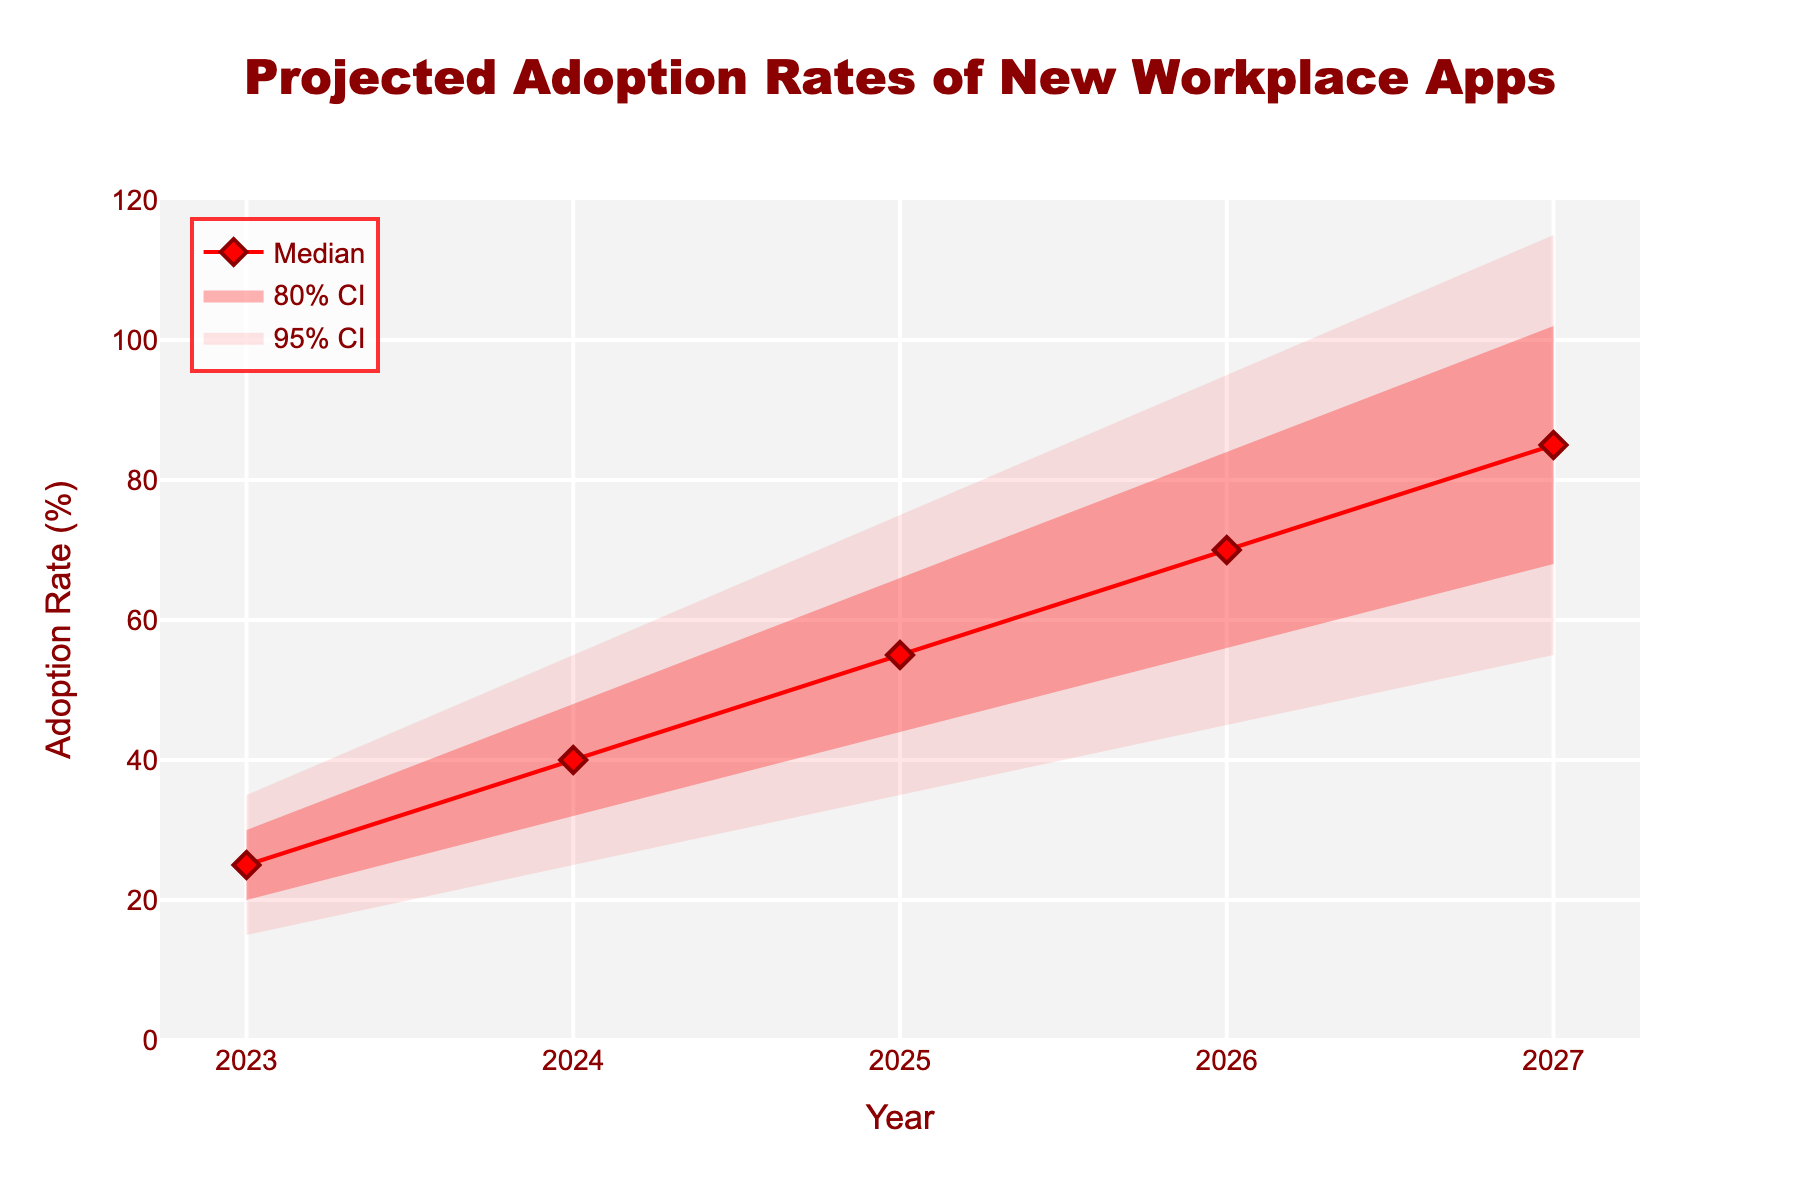What is the median projected adoption rate in 2025? Look at the median line in the plot and identify the value corresponding to the year 2025. It is represented by a red diamond marker.
Answer: 55% What range does the 95% confidence interval cover in 2024? Identify the lower and upper bounds of the 95% confidence interval for the year 2024 by looking at the shaded areas on the chart.
Answer: 25% to 55% How does the adoption rate change from 2023 to 2027 according to the median line? Track the median red line across the years from 2023 to 2027. Note the value increments year by year.
Answer: It increases from 25% to 85% Is the projected adoption rate more uncertain in 2025 or 2027 based on the width of the 95% confidence interval? Compare the width of the shaded area representing the 95% confidence interval in 2025 and 2027.
Answer: More uncertain in 2027 What is the difference between the upper 80% CI and the median in 2026? Locate the upper 80% CI and the median for the year 2026, then subtract the median from the upper 80% CI.
Answer: 84% - 70% = 14% Which year has the smallest range for the 80% confidence interval? Compare the widths of the 80% confidence intervals (the middle-shaded section) for all years and identify the year with the smallest range.
Answer: 2023 Is the increase in the median adoption rate from 2024 to 2025 greater than from 2025 to 2026? Calculate the differences in the median values between the years 2024 & 2025, and 2025 & 2026, then compare them.
Answer: Yes, it is greater from 2024 to 2025 What is the adoption rate for the lower 95% CI in 2027? Identify the value that represents the lower bound of the 95% confidence interval in 2027.
Answer: 55% Based on the fan chart, can we say the adoption rate will definitely be above 30% in 2024 with 95% confidence? Check whether the lower bound of the 95% confidence interval in 2024 is above 30%.
Answer: No How much does the upper 95% confidence interval change from 2024 to 2027? Subtract the upper 95% confidence interval value in 2024 from the value in 2027.
Answer: 115% - 55% = 60% 